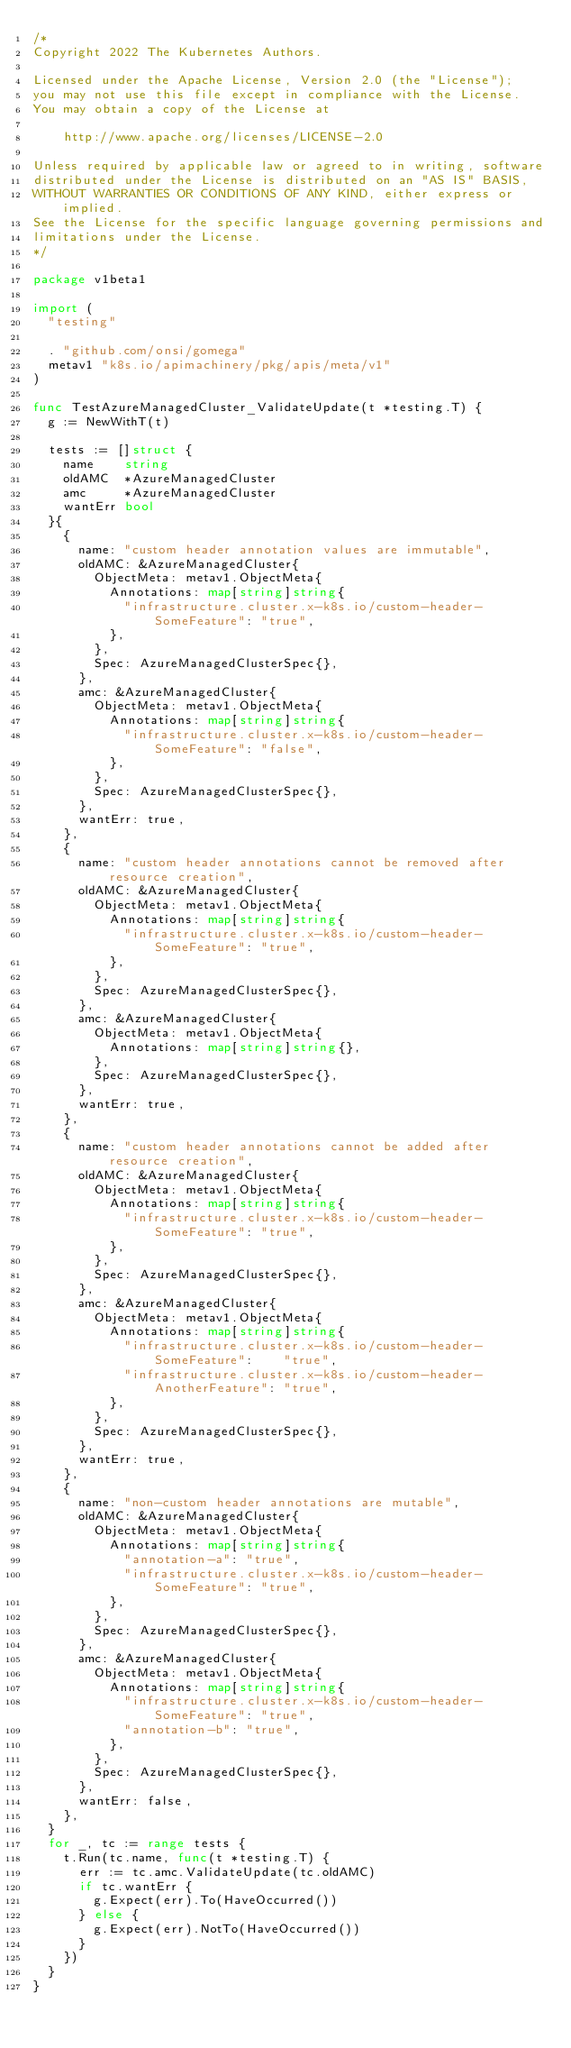Convert code to text. <code><loc_0><loc_0><loc_500><loc_500><_Go_>/*
Copyright 2022 The Kubernetes Authors.

Licensed under the Apache License, Version 2.0 (the "License");
you may not use this file except in compliance with the License.
You may obtain a copy of the License at

    http://www.apache.org/licenses/LICENSE-2.0

Unless required by applicable law or agreed to in writing, software
distributed under the License is distributed on an "AS IS" BASIS,
WITHOUT WARRANTIES OR CONDITIONS OF ANY KIND, either express or implied.
See the License for the specific language governing permissions and
limitations under the License.
*/

package v1beta1

import (
	"testing"

	. "github.com/onsi/gomega"
	metav1 "k8s.io/apimachinery/pkg/apis/meta/v1"
)

func TestAzureManagedCluster_ValidateUpdate(t *testing.T) {
	g := NewWithT(t)

	tests := []struct {
		name    string
		oldAMC  *AzureManagedCluster
		amc     *AzureManagedCluster
		wantErr bool
	}{
		{
			name: "custom header annotation values are immutable",
			oldAMC: &AzureManagedCluster{
				ObjectMeta: metav1.ObjectMeta{
					Annotations: map[string]string{
						"infrastructure.cluster.x-k8s.io/custom-header-SomeFeature": "true",
					},
				},
				Spec: AzureManagedClusterSpec{},
			},
			amc: &AzureManagedCluster{
				ObjectMeta: metav1.ObjectMeta{
					Annotations: map[string]string{
						"infrastructure.cluster.x-k8s.io/custom-header-SomeFeature": "false",
					},
				},
				Spec: AzureManagedClusterSpec{},
			},
			wantErr: true,
		},
		{
			name: "custom header annotations cannot be removed after resource creation",
			oldAMC: &AzureManagedCluster{
				ObjectMeta: metav1.ObjectMeta{
					Annotations: map[string]string{
						"infrastructure.cluster.x-k8s.io/custom-header-SomeFeature": "true",
					},
				},
				Spec: AzureManagedClusterSpec{},
			},
			amc: &AzureManagedCluster{
				ObjectMeta: metav1.ObjectMeta{
					Annotations: map[string]string{},
				},
				Spec: AzureManagedClusterSpec{},
			},
			wantErr: true,
		},
		{
			name: "custom header annotations cannot be added after resource creation",
			oldAMC: &AzureManagedCluster{
				ObjectMeta: metav1.ObjectMeta{
					Annotations: map[string]string{
						"infrastructure.cluster.x-k8s.io/custom-header-SomeFeature": "true",
					},
				},
				Spec: AzureManagedClusterSpec{},
			},
			amc: &AzureManagedCluster{
				ObjectMeta: metav1.ObjectMeta{
					Annotations: map[string]string{
						"infrastructure.cluster.x-k8s.io/custom-header-SomeFeature":    "true",
						"infrastructure.cluster.x-k8s.io/custom-header-AnotherFeature": "true",
					},
				},
				Spec: AzureManagedClusterSpec{},
			},
			wantErr: true,
		},
		{
			name: "non-custom header annotations are mutable",
			oldAMC: &AzureManagedCluster{
				ObjectMeta: metav1.ObjectMeta{
					Annotations: map[string]string{
						"annotation-a": "true",
						"infrastructure.cluster.x-k8s.io/custom-header-SomeFeature": "true",
					},
				},
				Spec: AzureManagedClusterSpec{},
			},
			amc: &AzureManagedCluster{
				ObjectMeta: metav1.ObjectMeta{
					Annotations: map[string]string{
						"infrastructure.cluster.x-k8s.io/custom-header-SomeFeature": "true",
						"annotation-b": "true",
					},
				},
				Spec: AzureManagedClusterSpec{},
			},
			wantErr: false,
		},
	}
	for _, tc := range tests {
		t.Run(tc.name, func(t *testing.T) {
			err := tc.amc.ValidateUpdate(tc.oldAMC)
			if tc.wantErr {
				g.Expect(err).To(HaveOccurred())
			} else {
				g.Expect(err).NotTo(HaveOccurred())
			}
		})
	}
}
</code> 